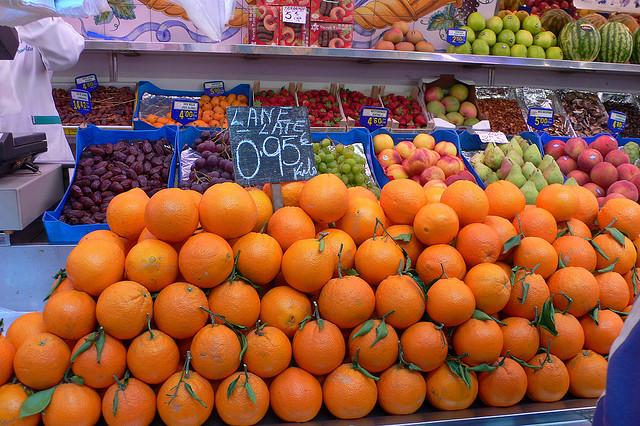How much is this fruit being sold for?
Concise answer only. .95. What kind of food is shown?
Be succinct. Fruits. What kind of oranges are they?
Be succinct. Navel. Is there a scale behind the produce?
Give a very brief answer. No. How many types of fruit are there?
Write a very short answer. 15. What is the name of each type of food displayed here?
Keep it brief. Fruit. How much is the price for a kilogram of these fruits?
Concise answer only. .95. What shape do these oranges form?
Be succinct. Circle. 